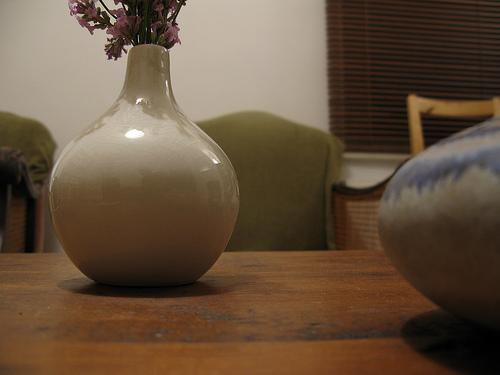Point out the main focus of the image and its surroundings. The main focus is a white vase with flowers on a wooden table, with a green chair and brown blinds nearby. List the items in the image and their respective shades. White vase, green and pink flowers, brown wooden table, green chair back, brown blinds, and light reflected. Mention the prominent colors and objects in the image. White vase, green and pink flowers, green chair, brown table, and brown window blinds. Give a comprehensive description of the primary object and how it correlates with its environment. A white, shiny, round-bottom vase with flowers is sitting on a dark brown wooden table, accompanied by a green chair and brown blinds in the background. Provide a brief summary of the primary contents of the image. A white vase with flowers on a brown wooden table, with a green chair and brown blinds in the background. In the image, outline the main subject and its correlation with other visible elements. The main subject is a white vase with flowers, which is placed on a brown wooden table, with a green chair and brown window blinds in the vicinity. What type of furniture is placed in the image and their colors? A brown wooden table, a green chair, and brown window blinds are present in the image. Express the central-theme of the image in one detailed sentence. The image captures a serene moment of a white, shiny vase with colorful flowers placed on a brown wooden table by a green chair and brown blinds. Describe the key components in the setting, including objects and colors. White vase with green, pink, and purple flowers, a brown table, a green chair, and brown window blinds. Mention the primary object in the image, and describe its visual interaction with other elements. The main object is a white vase with flowers, which contrasts well with the brown table, green chair, and brown blinds surrounding it. 